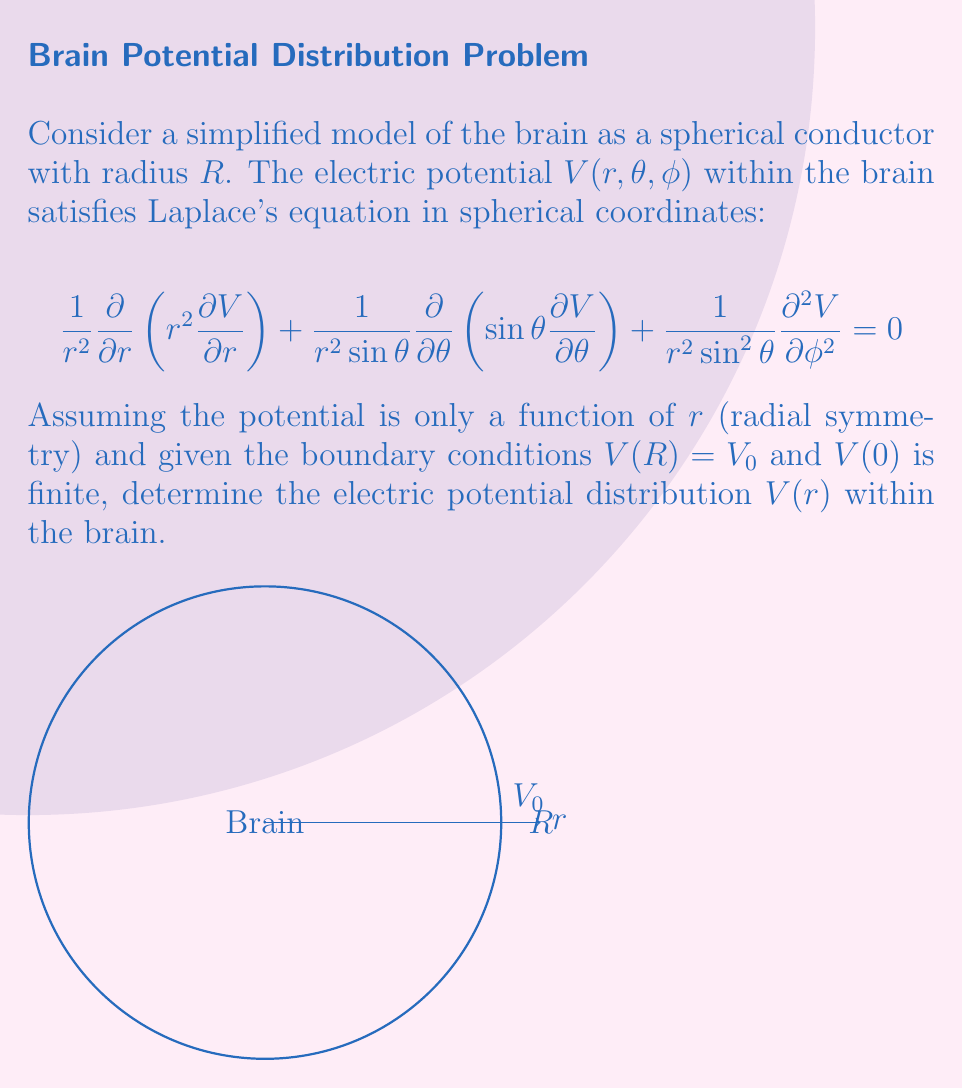Give your solution to this math problem. To solve this problem, we'll follow these steps:

1) Given the radial symmetry assumption, Laplace's equation simplifies to:

   $$\frac{1}{r^2}\frac{d}{dr}\left(r^2\frac{dV}{dr}\right) = 0$$

2) Multiply both sides by $r^2$:

   $$\frac{d}{dr}\left(r^2\frac{dV}{dr}\right) = 0$$

3) Integrate both sides with respect to $r$:

   $$r^2\frac{dV}{dr} = C_1$$

   where $C_1$ is a constant of integration.

4) Divide both sides by $r^2$ and integrate again:

   $$V(r) = -\frac{C_1}{r} + C_2$$

   where $C_2$ is another constant of integration.

5) Apply the boundary conditions:
   
   a) $V(R) = V_0$: 
      $$V_0 = -\frac{C_1}{R} + C_2$$
   
   b) $V(0)$ is finite: This implies $C_1 = 0$, otherwise $V(r)$ would approach infinity as $r$ approaches 0.

6) With $C_1 = 0$, we have $V(r) = C_2 = V_0$ for all $r$.

Therefore, the electric potential distribution within the brain is constant and equal to the surface potential $V_0$.
Answer: $V(r) = V_0$ 